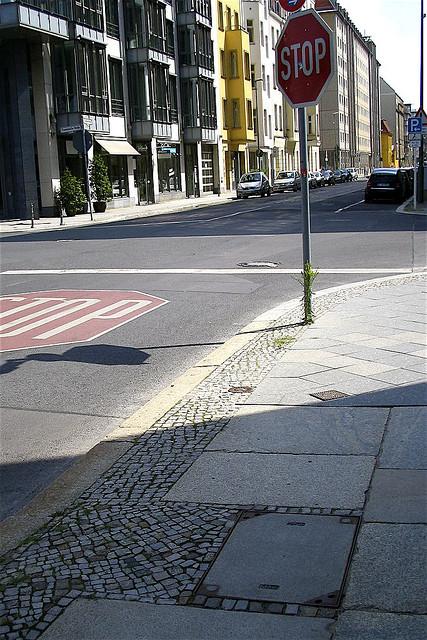What does the red sign say?
Short answer required. Stop. What are you expected to do when arriving at the sign in the photo?
Concise answer only. Stop. What sign is shown across the street past the stop sign?
Concise answer only. Parking. 